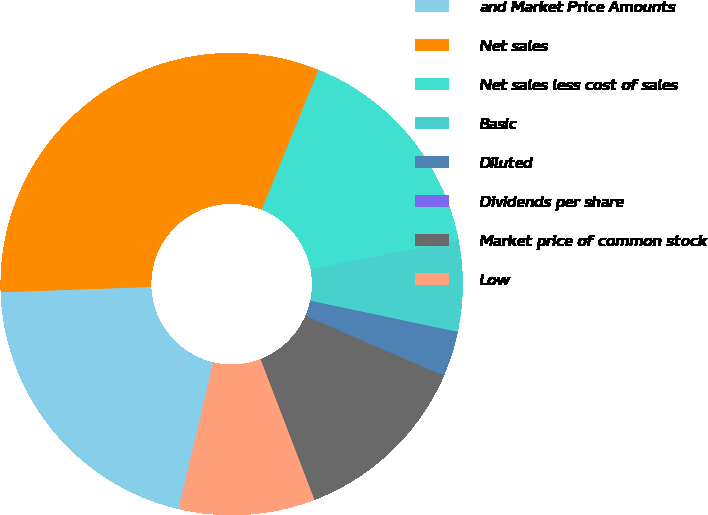Convert chart to OTSL. <chart><loc_0><loc_0><loc_500><loc_500><pie_chart><fcel>and Market Price Amounts<fcel>Net sales<fcel>Net sales less cost of sales<fcel>Basic<fcel>Diluted<fcel>Dividends per share<fcel>Market price of common stock<fcel>Low<nl><fcel>20.76%<fcel>31.69%<fcel>15.85%<fcel>6.34%<fcel>3.17%<fcel>0.0%<fcel>12.68%<fcel>9.51%<nl></chart> 